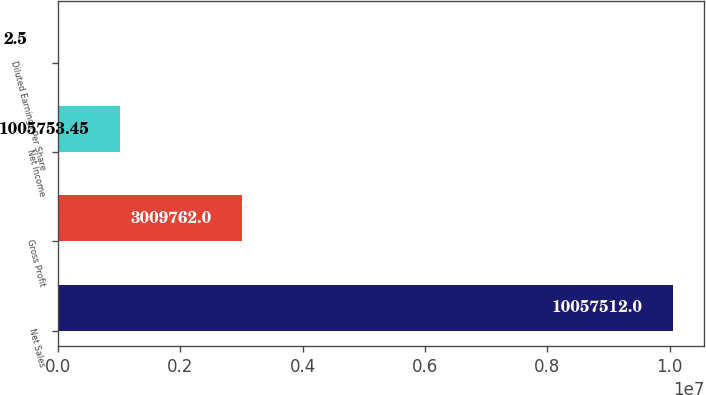Convert chart. <chart><loc_0><loc_0><loc_500><loc_500><bar_chart><fcel>Net Sales<fcel>Gross Profit<fcel>Net Income<fcel>Diluted Earnings Per Share<nl><fcel>1.00575e+07<fcel>3.00976e+06<fcel>1.00575e+06<fcel>2.5<nl></chart> 